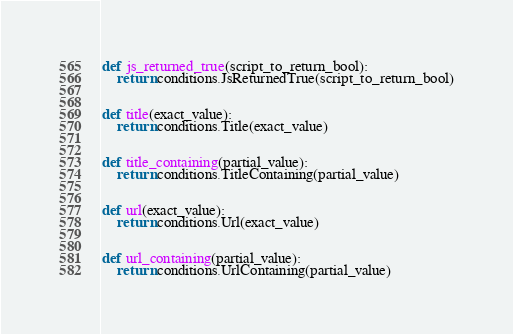Convert code to text. <code><loc_0><loc_0><loc_500><loc_500><_Python_>

def js_returned_true(script_to_return_bool):
    return conditions.JsReturnedTrue(script_to_return_bool)


def title(exact_value):
    return conditions.Title(exact_value)


def title_containing(partial_value):
    return conditions.TitleContaining(partial_value)


def url(exact_value):
    return conditions.Url(exact_value)


def url_containing(partial_value):
    return conditions.UrlContaining(partial_value)
</code> 